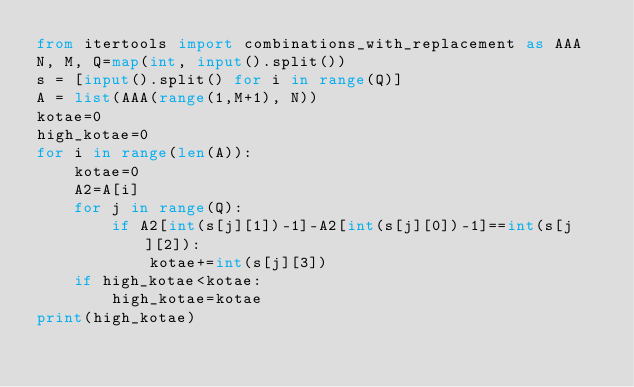<code> <loc_0><loc_0><loc_500><loc_500><_Python_>from itertools import combinations_with_replacement as AAA
N, M, Q=map(int, input().split())
s = [input().split() for i in range(Q)]
A = list(AAA(range(1,M+1), N))
kotae=0
high_kotae=0
for i in range(len(A)):
    kotae=0
    A2=A[i]
    for j in range(Q):
        if A2[int(s[j][1])-1]-A2[int(s[j][0])-1]==int(s[j][2]):
            kotae+=int(s[j][3])
    if high_kotae<kotae:
        high_kotae=kotae
print(high_kotae)</code> 